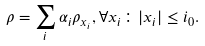<formula> <loc_0><loc_0><loc_500><loc_500>\rho = \sum _ { i } \alpha _ { i } \rho _ { x _ { i } } , \forall x _ { i } \colon | x _ { i } | \leq i _ { 0 } .</formula> 